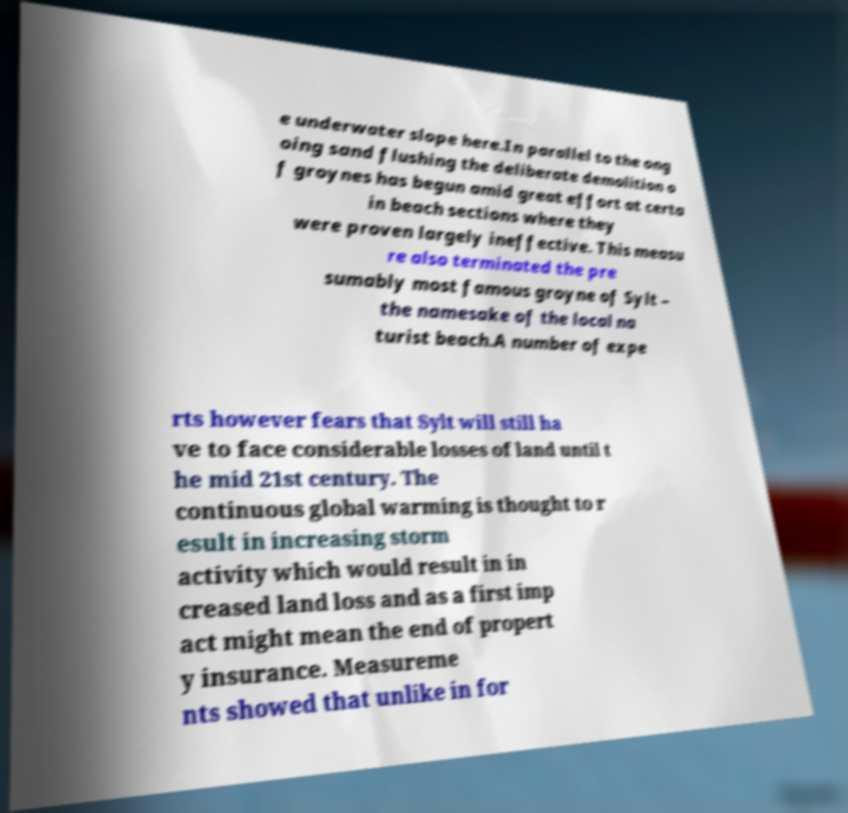I need the written content from this picture converted into text. Can you do that? e underwater slope here.In parallel to the ong oing sand flushing the deliberate demolition o f groynes has begun amid great effort at certa in beach sections where they were proven largely ineffective. This measu re also terminated the pre sumably most famous groyne of Sylt – the namesake of the local na turist beach.A number of expe rts however fears that Sylt will still ha ve to face considerable losses of land until t he mid 21st century. The continuous global warming is thought to r esult in increasing storm activity which would result in in creased land loss and as a first imp act might mean the end of propert y insurance. Measureme nts showed that unlike in for 